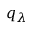Convert formula to latex. <formula><loc_0><loc_0><loc_500><loc_500>q _ { \lambda }</formula> 